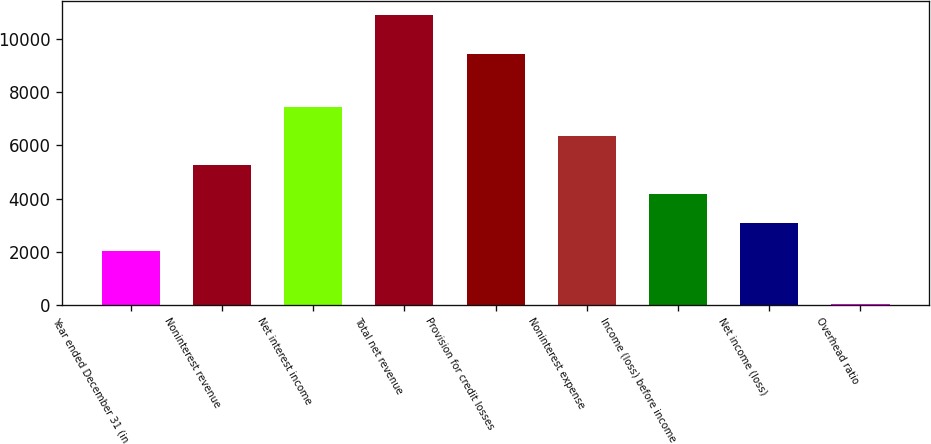<chart> <loc_0><loc_0><loc_500><loc_500><bar_chart><fcel>Year ended December 31 (in<fcel>Noninterest revenue<fcel>Net interest income<fcel>Total net revenue<fcel>Provision for credit losses<fcel>Noninterest expense<fcel>Income (loss) before income<fcel>Net income (loss)<fcel>Overhead ratio<nl><fcel>2008<fcel>5267.8<fcel>7441<fcel>10910<fcel>9456<fcel>6354.4<fcel>4181.2<fcel>3094.6<fcel>44<nl></chart> 